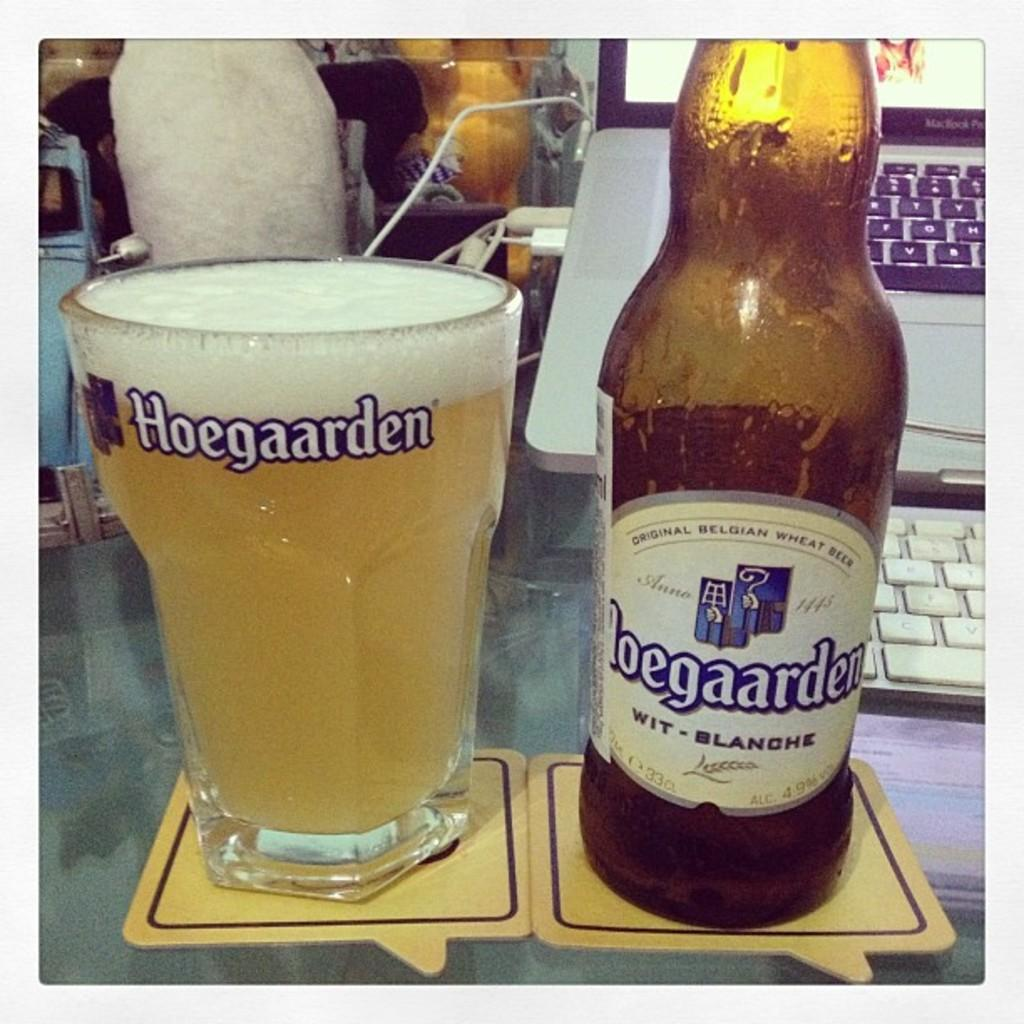What is in the glass that is visible in the image? There is a glass of wine in the image. What else is on the table in the image? There is a bottle and a laptop on the table. What brand name is associated with the wine in the image? The brand name "Hoegaarden" is written on the bottle and glass. What type of cave is visible in the background of the image? There is no cave present in the image; it features a glass of wine, a bottle, and a laptop on a table. 